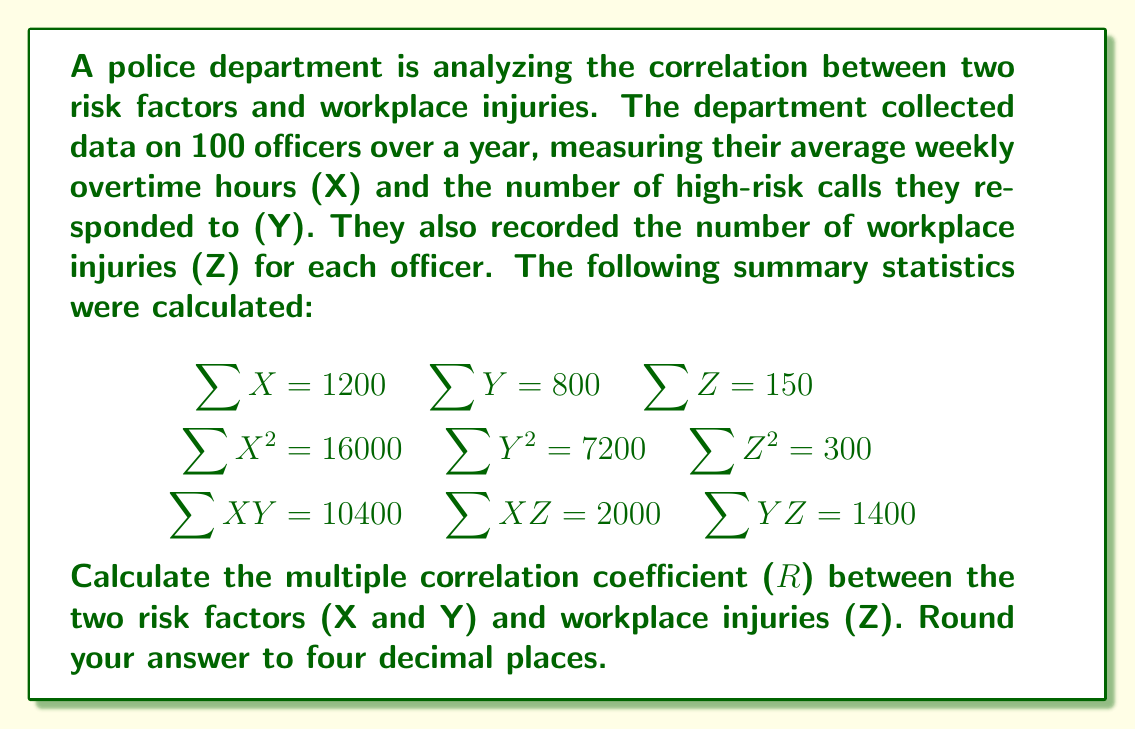Show me your answer to this math problem. To calculate the multiple correlation coefficient, we'll follow these steps:

1. Calculate the means of X, Y, and Z:
   $$\bar{X} = \frac{\sum X}{n} = \frac{1200}{100} = 12$$
   $$\bar{Y} = \frac{\sum Y}{n} = \frac{800}{100} = 8$$
   $$\bar{Z} = \frac{\sum Z}{n} = \frac{150}{100} = 1.5$$

2. Calculate the variances and covariances:
   $$s_X^2 = \frac{\sum X^2}{n} - \bar{X}^2 = \frac{16000}{100} - 12^2 = 16$$
   $$s_Y^2 = \frac{\sum Y^2}{n} - \bar{Y}^2 = \frac{7200}{100} - 8^2 = 8$$
   $$s_Z^2 = \frac{\sum Z^2}{n} - \bar{Z}^2 = \frac{300}{100} - 1.5^2 = 0.75$$
   $$s_{XY} = \frac{\sum XY}{n} - \bar{X}\bar{Y} = \frac{10400}{100} - 12 \cdot 8 = 8$$
   $$s_{XZ} = \frac{\sum XZ}{n} - \bar{X}\bar{Z} = \frac{2000}{100} - 12 \cdot 1.5 = 2$$
   $$s_{YZ} = \frac{\sum YZ}{n} - \bar{Y}\bar{Z} = \frac{1400}{100} - 8 \cdot 1.5 = 2$$

3. Calculate the correlation coefficients:
   $$r_{XY} = \frac{s_{XY}}{s_X s_Y} = \frac{8}{\sqrt{16} \sqrt{8}} = 0.7071$$
   $$r_{XZ} = \frac{s_{XZ}}{s_X s_Z} = \frac{2}{\sqrt{16} \sqrt{0.75}} = 0.5774$$
   $$r_{YZ} = \frac{s_{YZ}}{s_Y s_Z} = \frac{2}{\sqrt{8} \sqrt{0.75}} = 0.8165$$

4. Calculate the multiple correlation coefficient:
   $$R = \sqrt{\frac{r_{XZ}^2 + r_{YZ}^2 - 2r_{XZ}r_{YZ}r_{XY}}{1 - r_{XY}^2}}$$
   
   Substituting the values:
   $$R = \sqrt{\frac{0.5774^2 + 0.8165^2 - 2(0.5774)(0.8165)(0.7071)}{1 - 0.7071^2}}$$
   
   $$R = \sqrt{\frac{0.3334 + 0.6667 - 0.6667}{1 - 0.5000}} = \sqrt{\frac{0.3334}{0.5000}} = \sqrt{0.6668} = 0.8166$$
Answer: The multiple correlation coefficient (R) between the two risk factors and workplace injuries is 0.8166. 